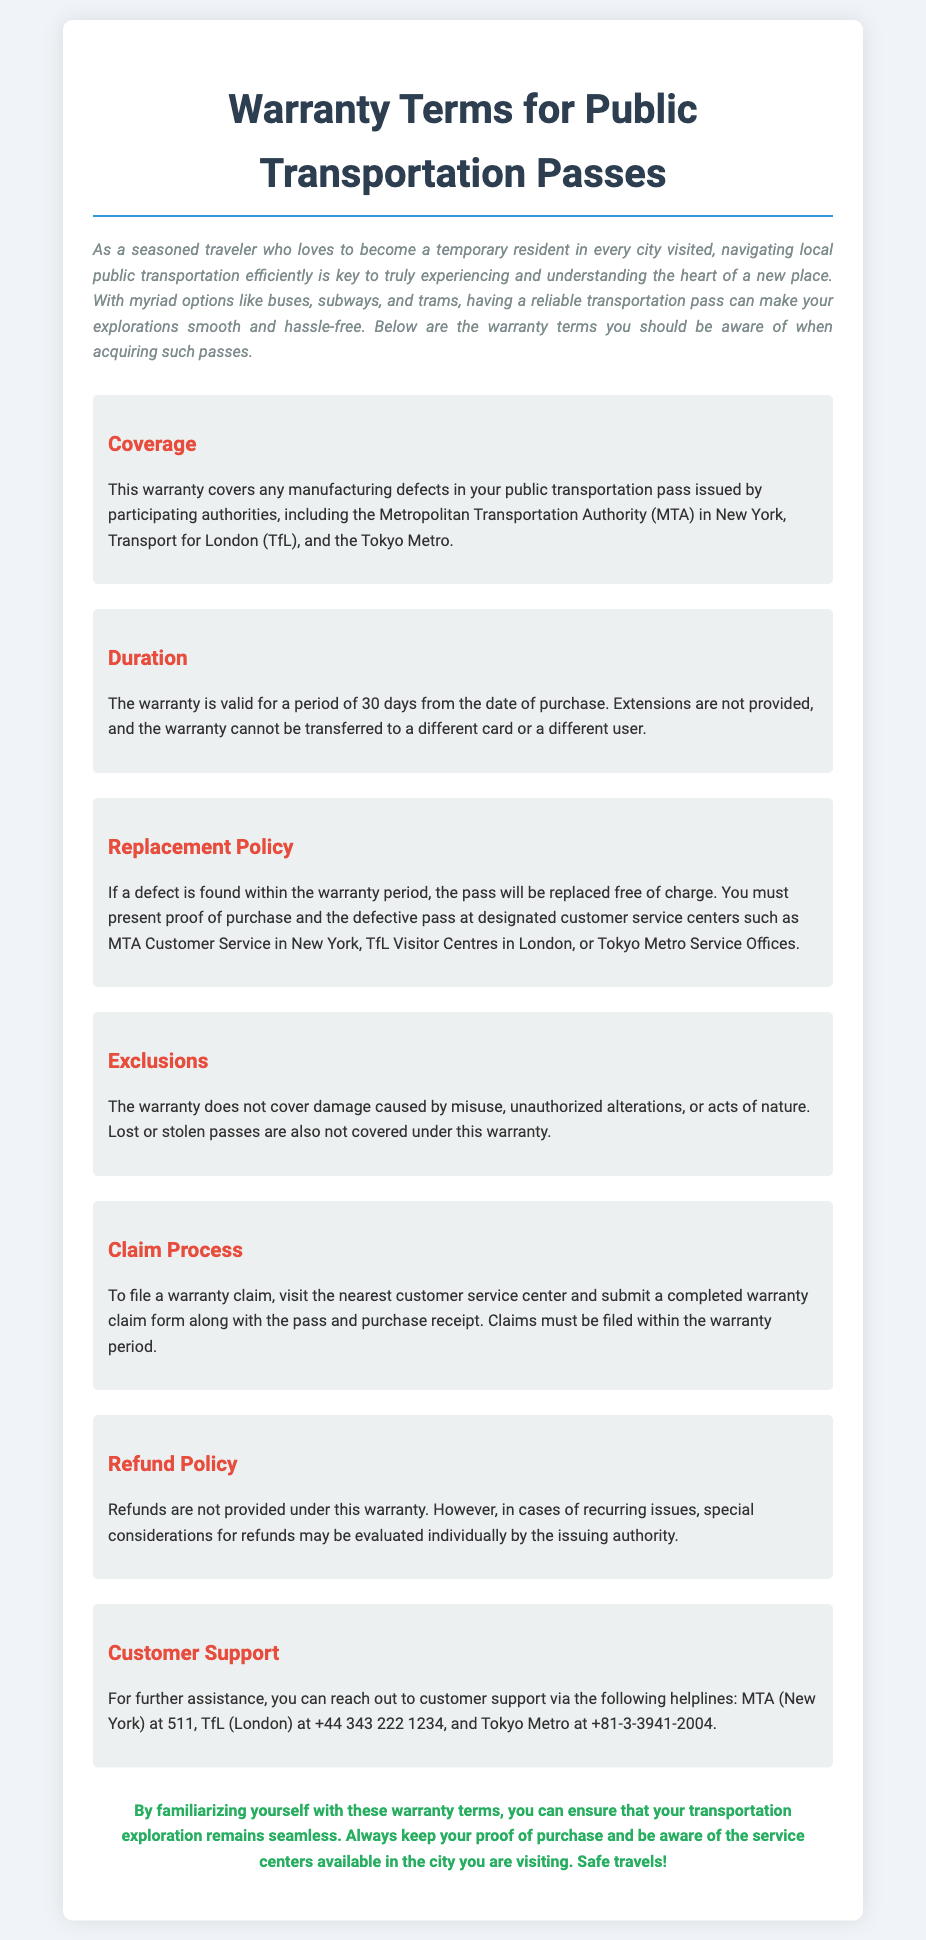What does the warranty cover? The warranty covers any manufacturing defects in your public transportation pass issued by participating authorities.
Answer: Manufacturing defects How long is the warranty valid? The warranty is valid for a period of 30 days from the date of purchase.
Answer: 30 days What must be presented to replace a defective pass? You must present proof of purchase and the defective pass at designated customer service centers.
Answer: Proof of purchase and defective pass What type of damage is excluded from the warranty? The warranty does not cover damage caused by misuse, unauthorized alterations, or acts of nature.
Answer: Misuse Where can you file a warranty claim? To file a warranty claim, visit the nearest customer service center and submit a completed warranty claim form.
Answer: Customer service center Are refunds provided under this warranty? Refunds are not provided under this warranty.
Answer: No What is the customer support helpline for MTA (New York)? For further assistance, MTA can be reached at 511.
Answer: 511 Is the warranty transferable? The warranty cannot be transferred to a different card or a different user.
Answer: No What criteria may lead to special consideration for a refund? Special considerations for refunds may be evaluated individually by the issuing authority in cases of recurring issues.
Answer: Recurring issues 